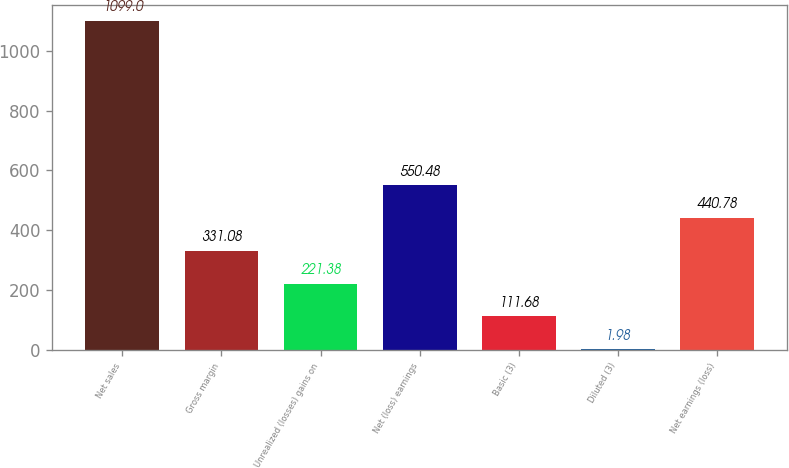Convert chart. <chart><loc_0><loc_0><loc_500><loc_500><bar_chart><fcel>Net sales<fcel>Gross margin<fcel>Unrealized (losses) gains on<fcel>Net (loss) earnings<fcel>Basic (3)<fcel>Diluted (3)<fcel>Net earnings (loss)<nl><fcel>1099<fcel>331.08<fcel>221.38<fcel>550.48<fcel>111.68<fcel>1.98<fcel>440.78<nl></chart> 